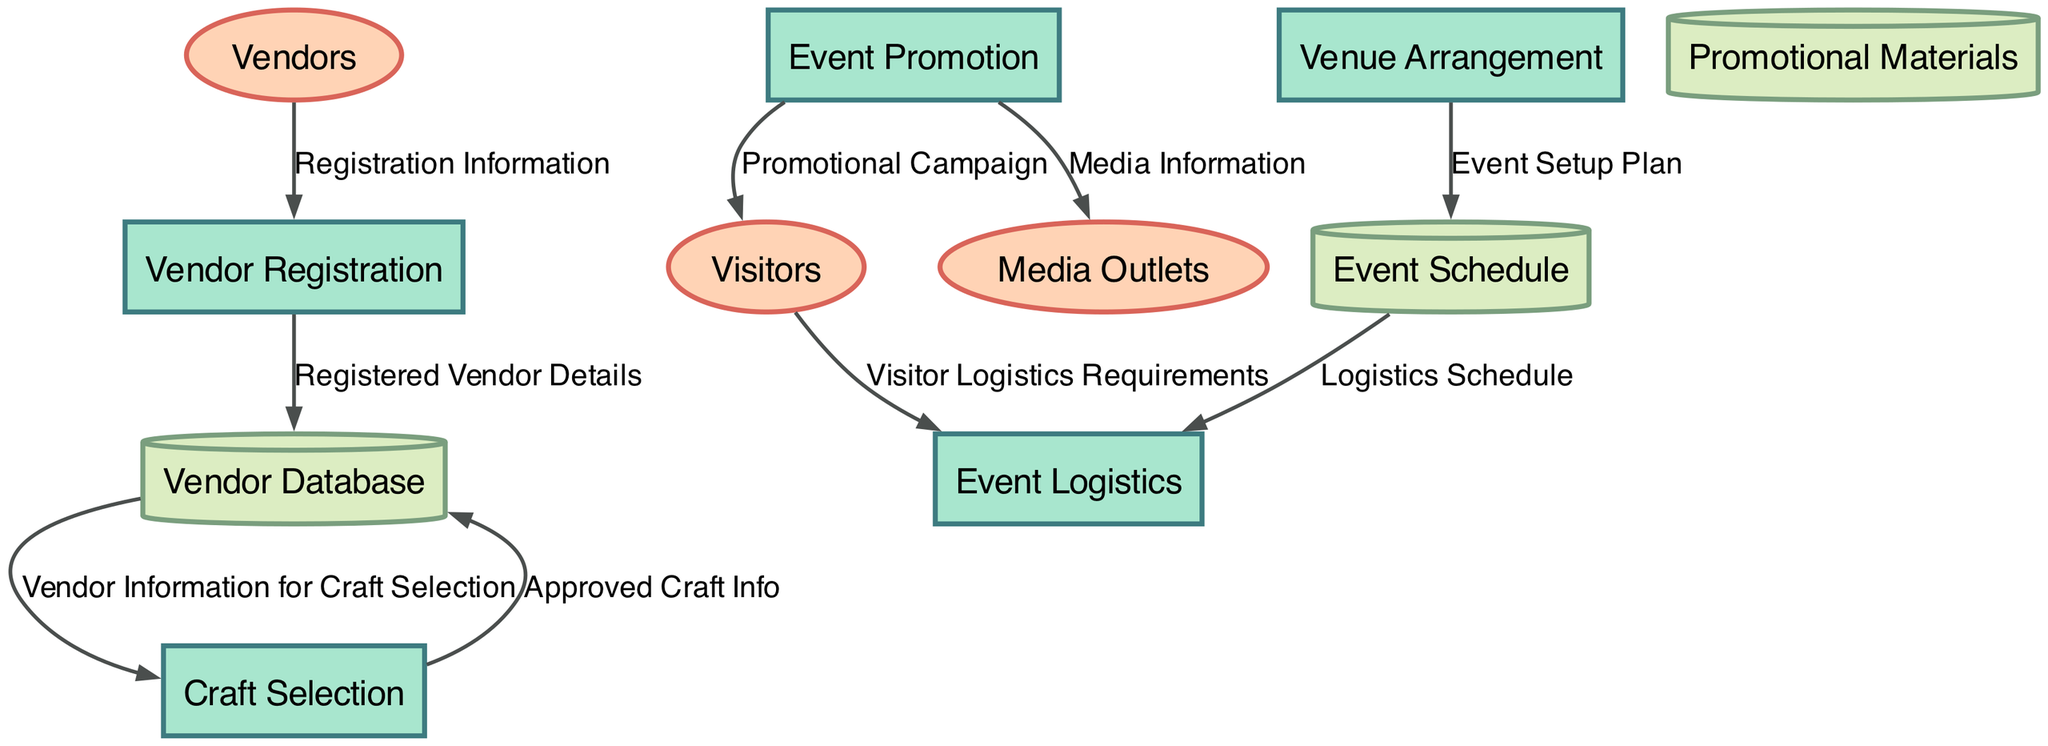What is the first process in the diagram? The first process listed in the diagram is "Vendor Registration," which is depicted as an initial step in organizing the fair.
Answer: Vendor Registration How many external entities are shown in the diagram? The diagram displays three external entities: Vendors, Visitors, and Media Outlets, which can be counted directly from the visual representation.
Answer: Three Which data store receives information from the "Vendor Registration" process? After the "Vendor Registration" process, the "Registered Vendor Details" flow is directed to the "Vendor Database," showing its connection to the registration process.
Answer: Vendor Database What are the logistical aspects coordinated in the "Event Logistics" process? The "Event Logistics" process coordinates transportation, security, and amenities, which are all necessary for the successful execution of the event, directly supporting event operations.
Answer: Transportation, security, and amenities What flow originates from the "Craft Selection" process? The flow that originates from "Craft Selection" is "Approved Craft Info," which moves back into the "Vendor Database," indicating that this information is recorded after approval.
Answer: Approved Craft Info Which external entity receives the promotional campaign? The promotional campaign is directed towards the "Visitors," which are external entities that the event aims to attract through promotion efforts.
Answer: Visitors How many processes are there in the diagram? There are five processes: Vendor Registration, Craft Selection, Event Promotion, Venue Arrangement, and Event Logistics, which can be tallied from the process list presented in the diagram.
Answer: Five Which process handles the event's setup plan? The "Venue Arrangement" process is responsible for creating the "Event Setup Plan," which is reflected in the flow directed to the Event Schedule.
Answer: Venue Arrangement What is the connection between "Event Promotion" and "Media Outlets"? The connection is established through the flow labeled "Media Information," which is sent from the "Event Promotion" process directly to "Media Outlets" for promotional dissemination.
Answer: Media Information 